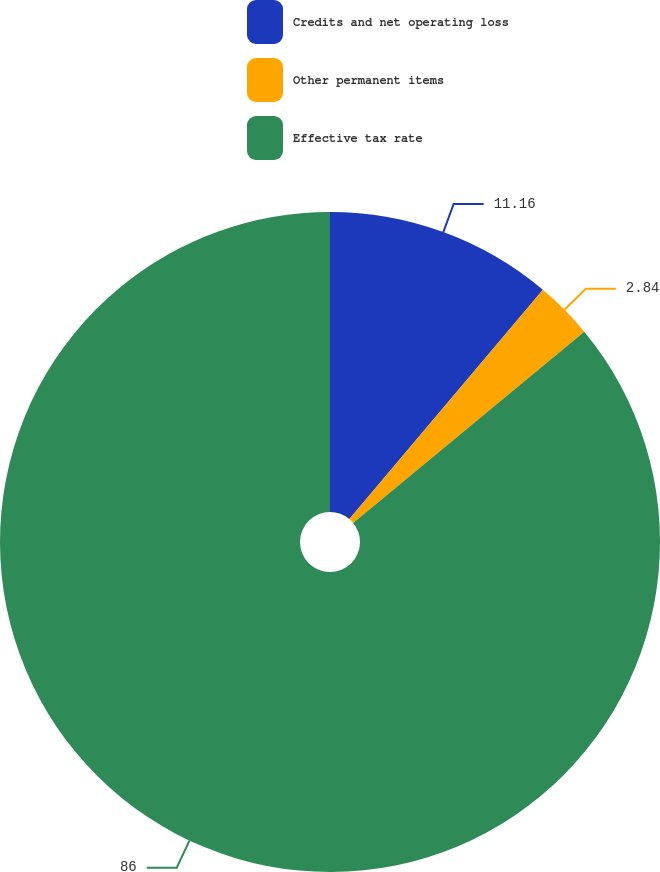Convert chart. <chart><loc_0><loc_0><loc_500><loc_500><pie_chart><fcel>Credits and net operating loss<fcel>Other permanent items<fcel>Effective tax rate<nl><fcel>11.16%<fcel>2.84%<fcel>86.0%<nl></chart> 